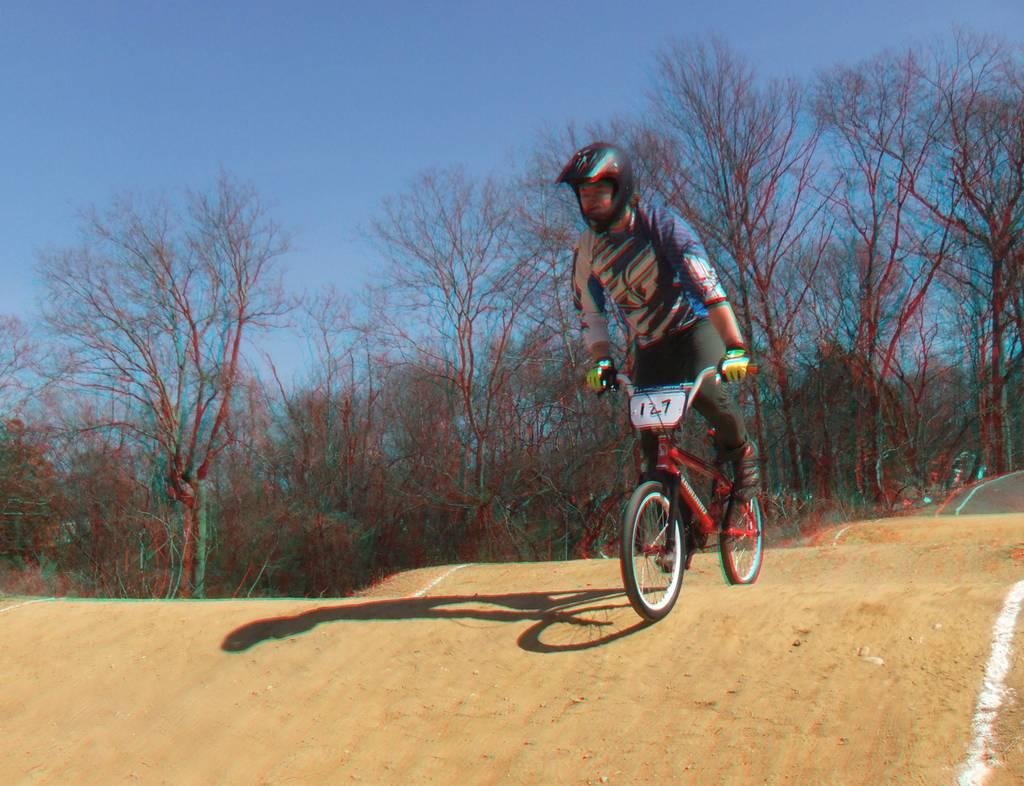What is the main subject of the image? There is a person in the image. What is the person doing in the image? The person is riding a bicycle. What can be seen in the background of the image? There are trees in the background of the image. How would you describe the weather based on the image? The sky is clear, suggesting good weather. What type of humor can be seen in the image? There is no humor depicted in the image; it shows a person riding a bicycle with trees in the background and a clear sky. Is there a bathtub present in the image? No, there is no bathtub or any reference to bathing in the image. 